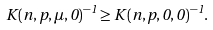<formula> <loc_0><loc_0><loc_500><loc_500>K ( n , p , \mu , 0 ) ^ { - 1 } \geq K ( n , p , 0 , 0 ) ^ { - 1 } .</formula> 